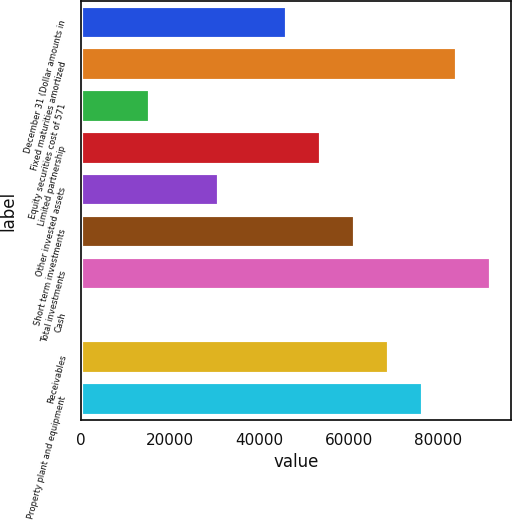Convert chart to OTSL. <chart><loc_0><loc_0><loc_500><loc_500><bar_chart><fcel>December 31 (Dollar amounts in<fcel>Fixed maturities amortized<fcel>Equity securities cost of 571<fcel>Limited partnership<fcel>Other invested assets<fcel>Short term investments<fcel>Total investments<fcel>Cash<fcel>Receivables<fcel>Property plant and equipment<nl><fcel>46087.2<fcel>84220.7<fcel>15580.4<fcel>53713.9<fcel>30833.8<fcel>61340.6<fcel>91847.4<fcel>327<fcel>68967.3<fcel>76594<nl></chart> 